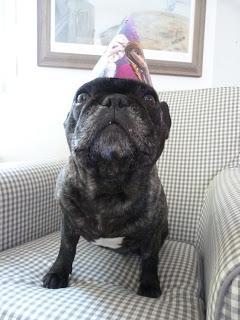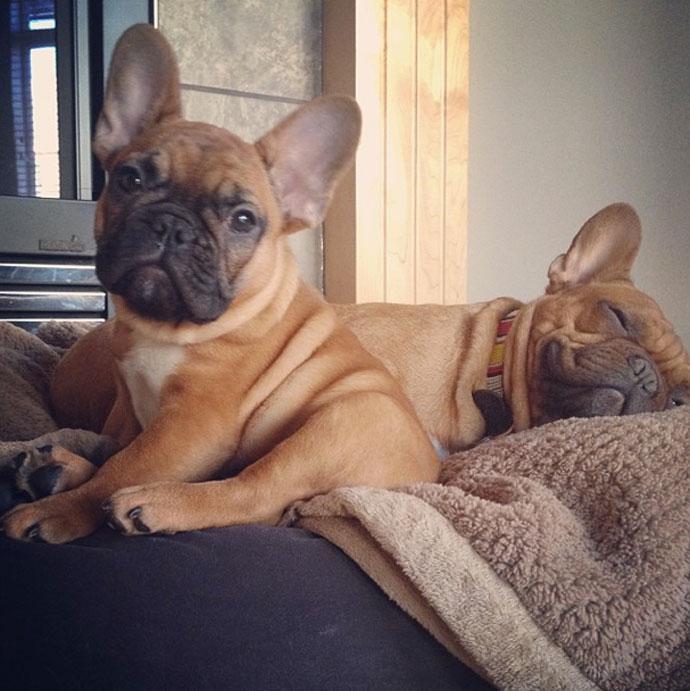The first image is the image on the left, the second image is the image on the right. For the images displayed, is the sentence "Two dogs are standing up in one of the images." factually correct? Answer yes or no. No. The first image is the image on the left, the second image is the image on the right. For the images shown, is this caption "Each image contains two big-eared dogs, and one pair of dogs includes a mostly black one and a mostly white one." true? Answer yes or no. No. 